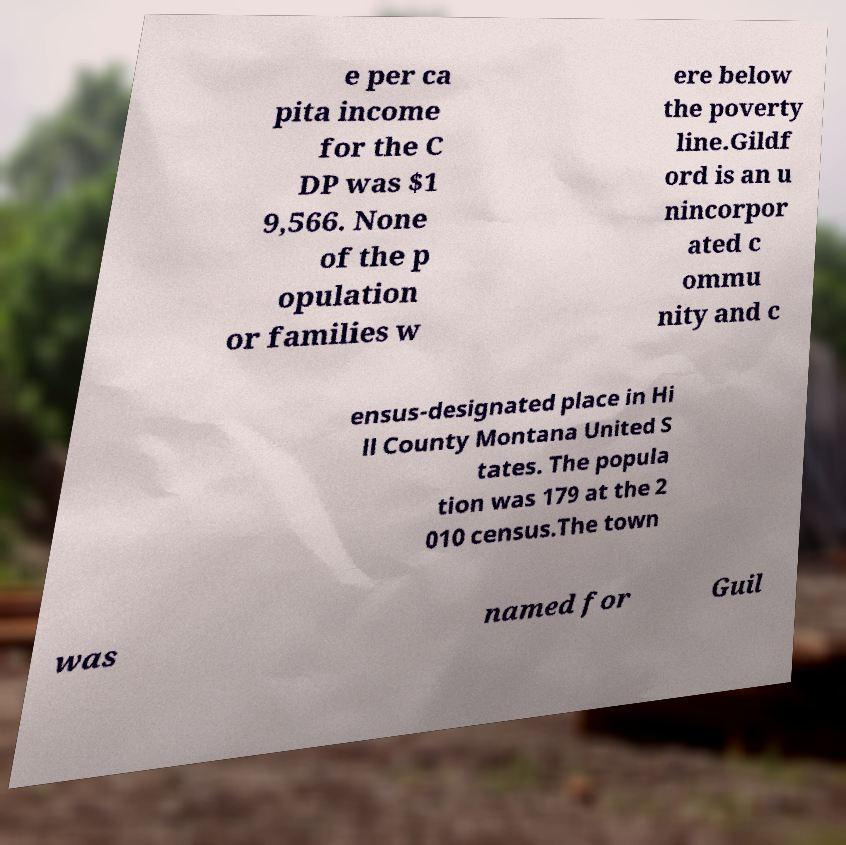Could you assist in decoding the text presented in this image and type it out clearly? e per ca pita income for the C DP was $1 9,566. None of the p opulation or families w ere below the poverty line.Gildf ord is an u nincorpor ated c ommu nity and c ensus-designated place in Hi ll County Montana United S tates. The popula tion was 179 at the 2 010 census.The town was named for Guil 